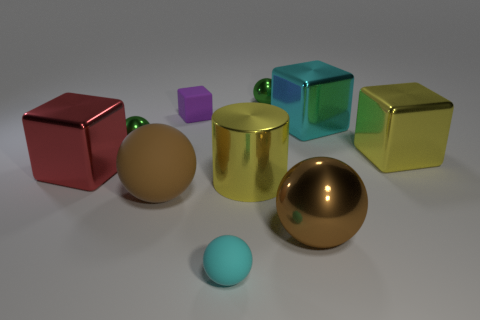What is the big yellow object to the right of the large cyan shiny thing made of? The big yellow object to the right of the large cyan object appears to be a glossy, metallic cylinder, suggestive of being made from a reflective metal such as gold-colored aluminum or a golden brass alloy, based on its shiny surface and coloration. 